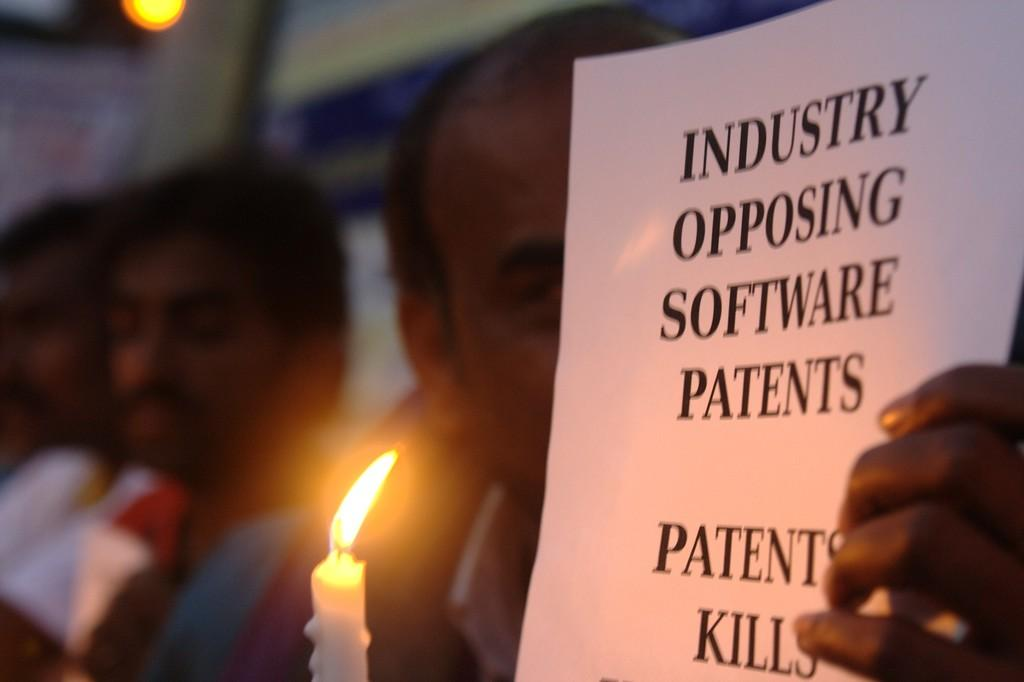How many people are in the image? There are a few people in the image. What is one person doing with a paper? One person is holding a paper with text. What else is the person holding along with the paper? The person holding the paper is also holding a candle. Can you describe the background of the image? The background of the image is blurred. What type of paint is being used to fill the bucket in the image? There is no paint or bucket present in the image. How much salt is visible on the person holding the paper in the image? There is no salt visible on the person holding the paper in the image. 